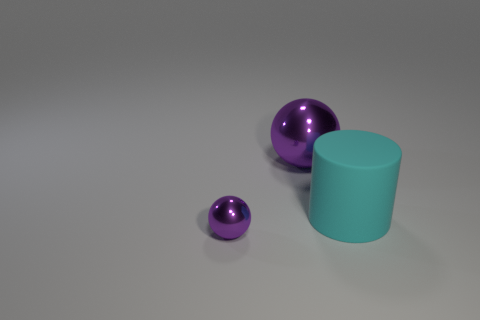Does the big rubber object have the same shape as the tiny metallic object?
Provide a succinct answer. No. The small shiny object is what color?
Keep it short and to the point. Purple. How many things are either big purple shiny balls or small purple shiny balls?
Provide a short and direct response. 2. Are there any other things that are the same material as the tiny object?
Give a very brief answer. Yes. Is the number of purple shiny balls that are behind the cyan thing less than the number of cyan cylinders?
Offer a terse response. No. Is the number of large shiny balls that are behind the large purple shiny ball greater than the number of big balls that are behind the cyan rubber cylinder?
Offer a very short reply. No. Is there anything else that is the same color as the small metallic ball?
Your answer should be very brief. Yes. What material is the large thing that is left of the big cyan thing?
Offer a terse response. Metal. What number of other objects are there of the same size as the cyan object?
Your answer should be very brief. 1. Is the small thing the same color as the rubber cylinder?
Offer a very short reply. No. 